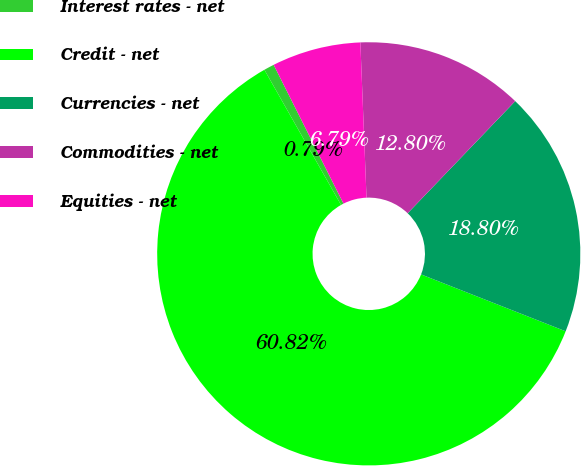Convert chart. <chart><loc_0><loc_0><loc_500><loc_500><pie_chart><fcel>Interest rates - net<fcel>Credit - net<fcel>Currencies - net<fcel>Commodities - net<fcel>Equities - net<nl><fcel>0.79%<fcel>60.83%<fcel>18.8%<fcel>12.8%<fcel>6.79%<nl></chart> 